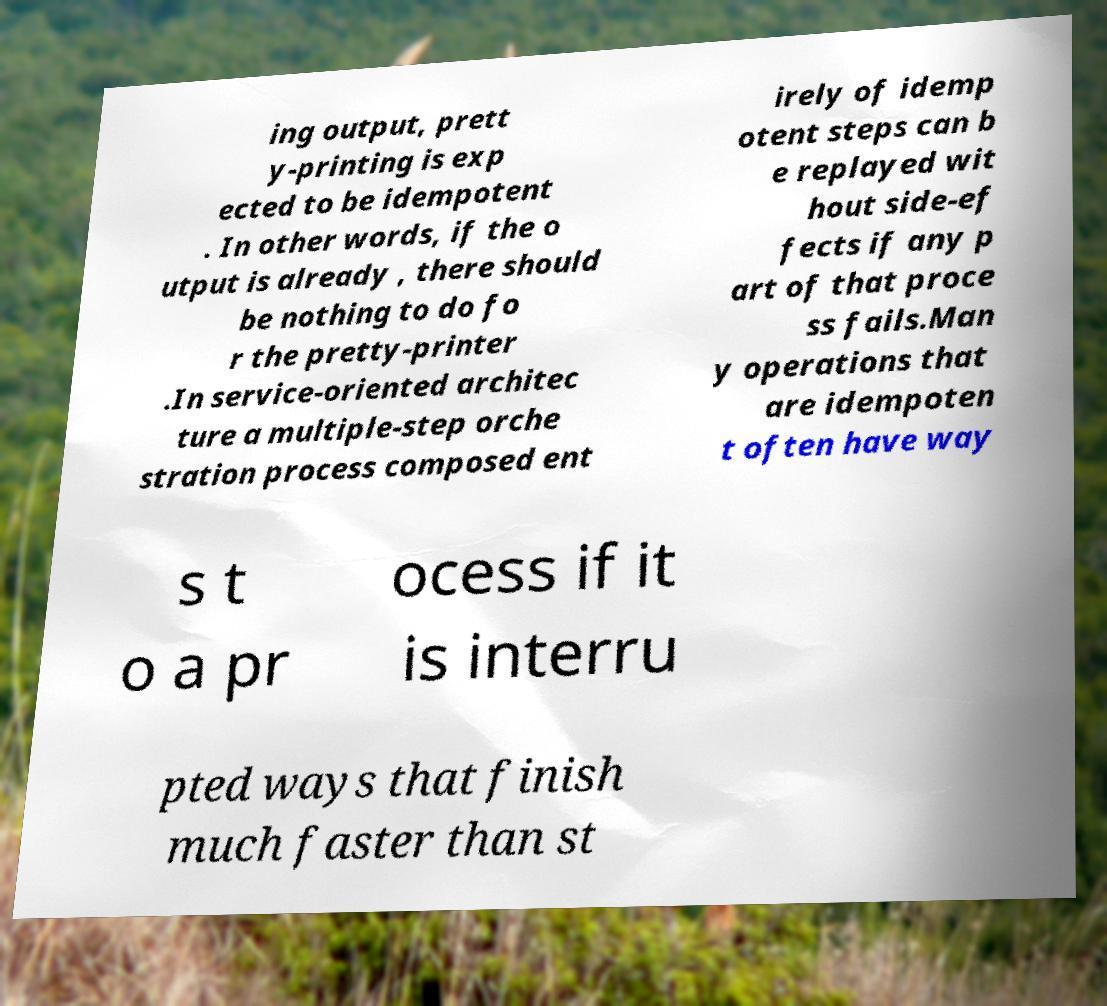Could you assist in decoding the text presented in this image and type it out clearly? ing output, prett y-printing is exp ected to be idempotent . In other words, if the o utput is already , there should be nothing to do fo r the pretty-printer .In service-oriented architec ture a multiple-step orche stration process composed ent irely of idemp otent steps can b e replayed wit hout side-ef fects if any p art of that proce ss fails.Man y operations that are idempoten t often have way s t o a pr ocess if it is interru pted ways that finish much faster than st 